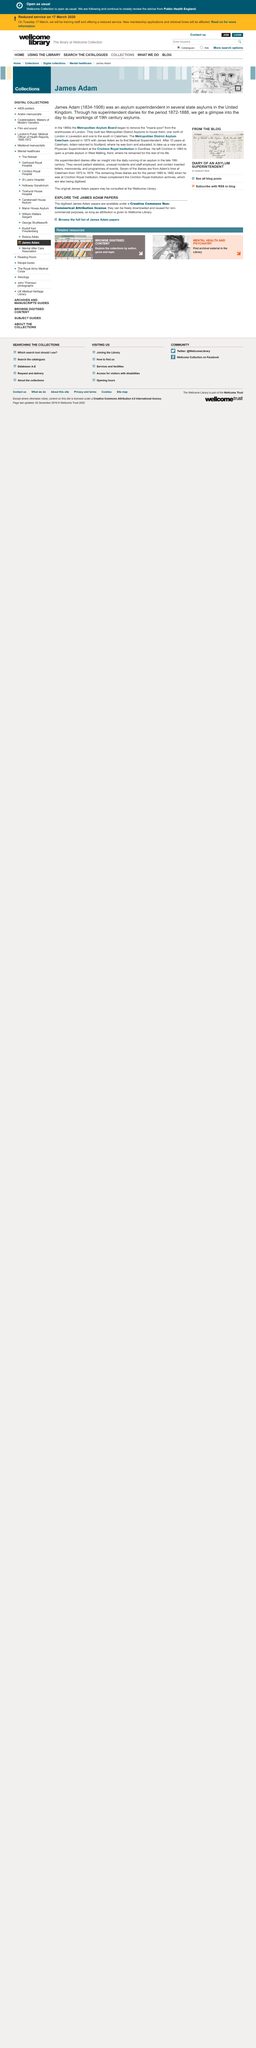Specify some key components in this picture. The image on top shows 'A Declaration of Independence', which is a document that declares the independence of a country from the rule of another country. The three remaining diaries cover the period from 1880 to 1882. In the 1860s, the Metropolitan Asylum Board began to remove the "insane poor" from the workhouses of London. 